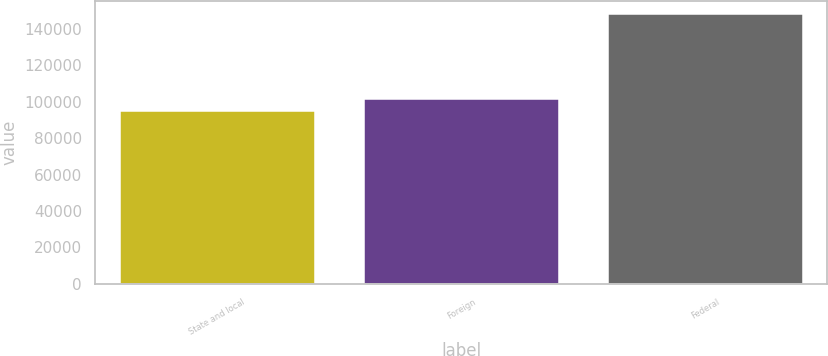Convert chart to OTSL. <chart><loc_0><loc_0><loc_500><loc_500><bar_chart><fcel>State and local<fcel>Foreign<fcel>Federal<nl><fcel>94763<fcel>101662<fcel>148094<nl></chart> 